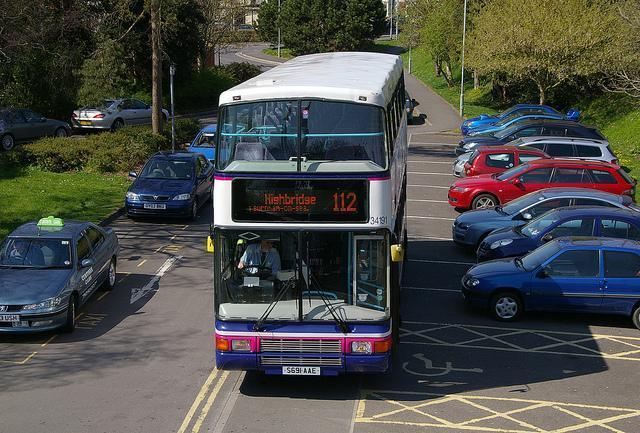How many cars are in the photo?
Give a very brief answer. 8. How many people are on their laptop in this image?
Give a very brief answer. 0. 